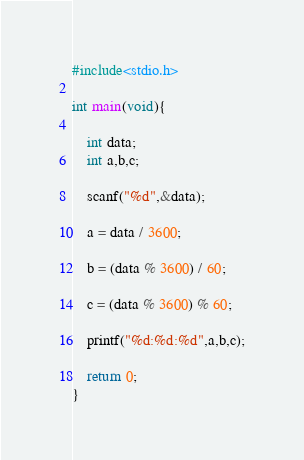Convert code to text. <code><loc_0><loc_0><loc_500><loc_500><_C_>#include<stdio.h>

int main(void){
    
    int data;
    int a,b,c;
    
    scanf("%d",&data);
    
    a = data / 3600;
    
    b = (data % 3600) / 60;
    
    c = (data % 3600) % 60;
    
    printf("%d:%d:%d",a,b,c);
    
    return 0;
}
</code> 